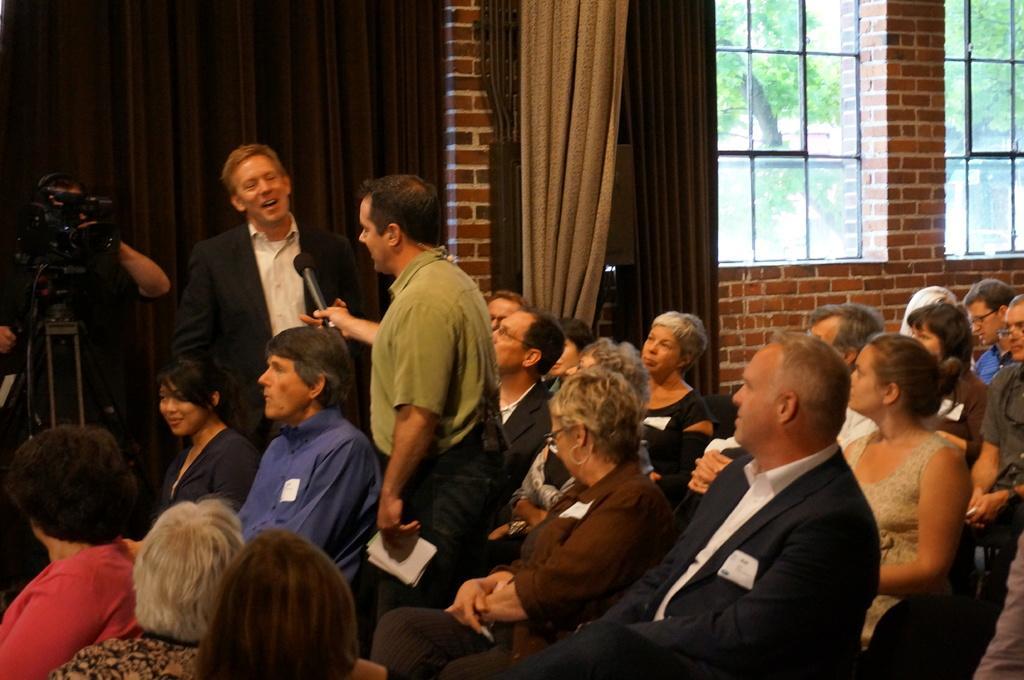Please provide a concise description of this image. People are sitting in a room. 2 people are standing. A person is holding a mic and other person is wearing suit. There is a camera, curtains and windows. 